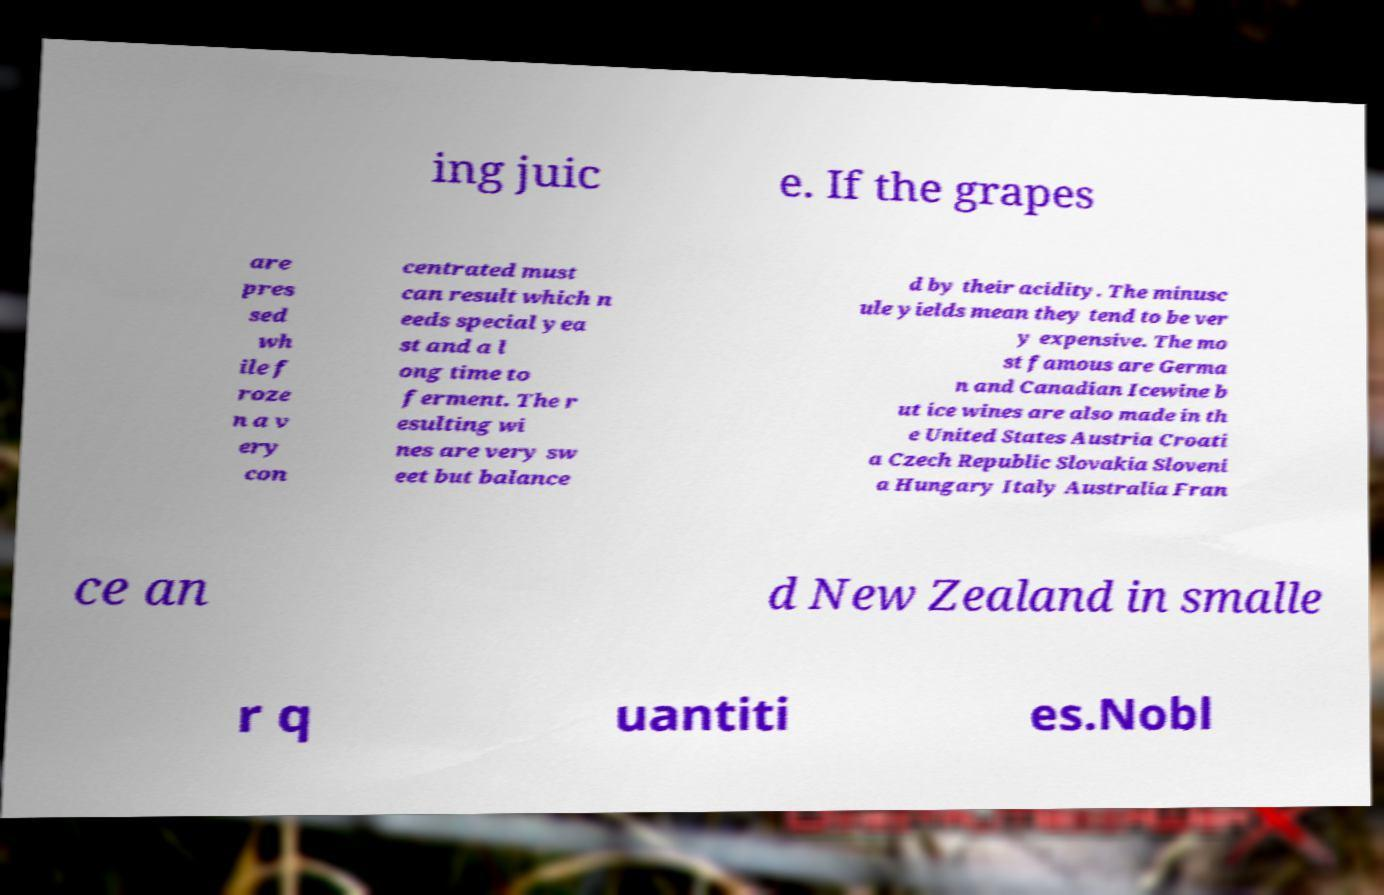Could you assist in decoding the text presented in this image and type it out clearly? ing juic e. If the grapes are pres sed wh ile f roze n a v ery con centrated must can result which n eeds special yea st and a l ong time to ferment. The r esulting wi nes are very sw eet but balance d by their acidity. The minusc ule yields mean they tend to be ver y expensive. The mo st famous are Germa n and Canadian Icewine b ut ice wines are also made in th e United States Austria Croati a Czech Republic Slovakia Sloveni a Hungary Italy Australia Fran ce an d New Zealand in smalle r q uantiti es.Nobl 